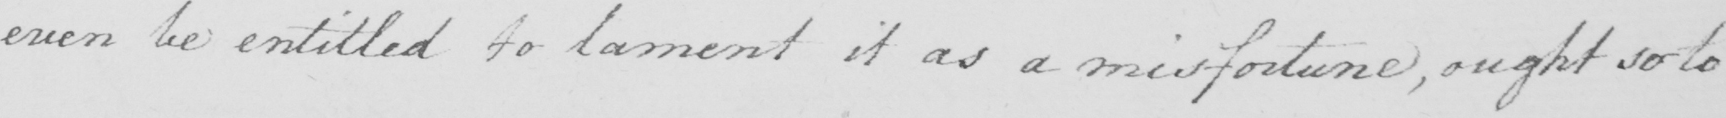Can you read and transcribe this handwriting? even be entitled to lament it as a misforturne , ought so to 